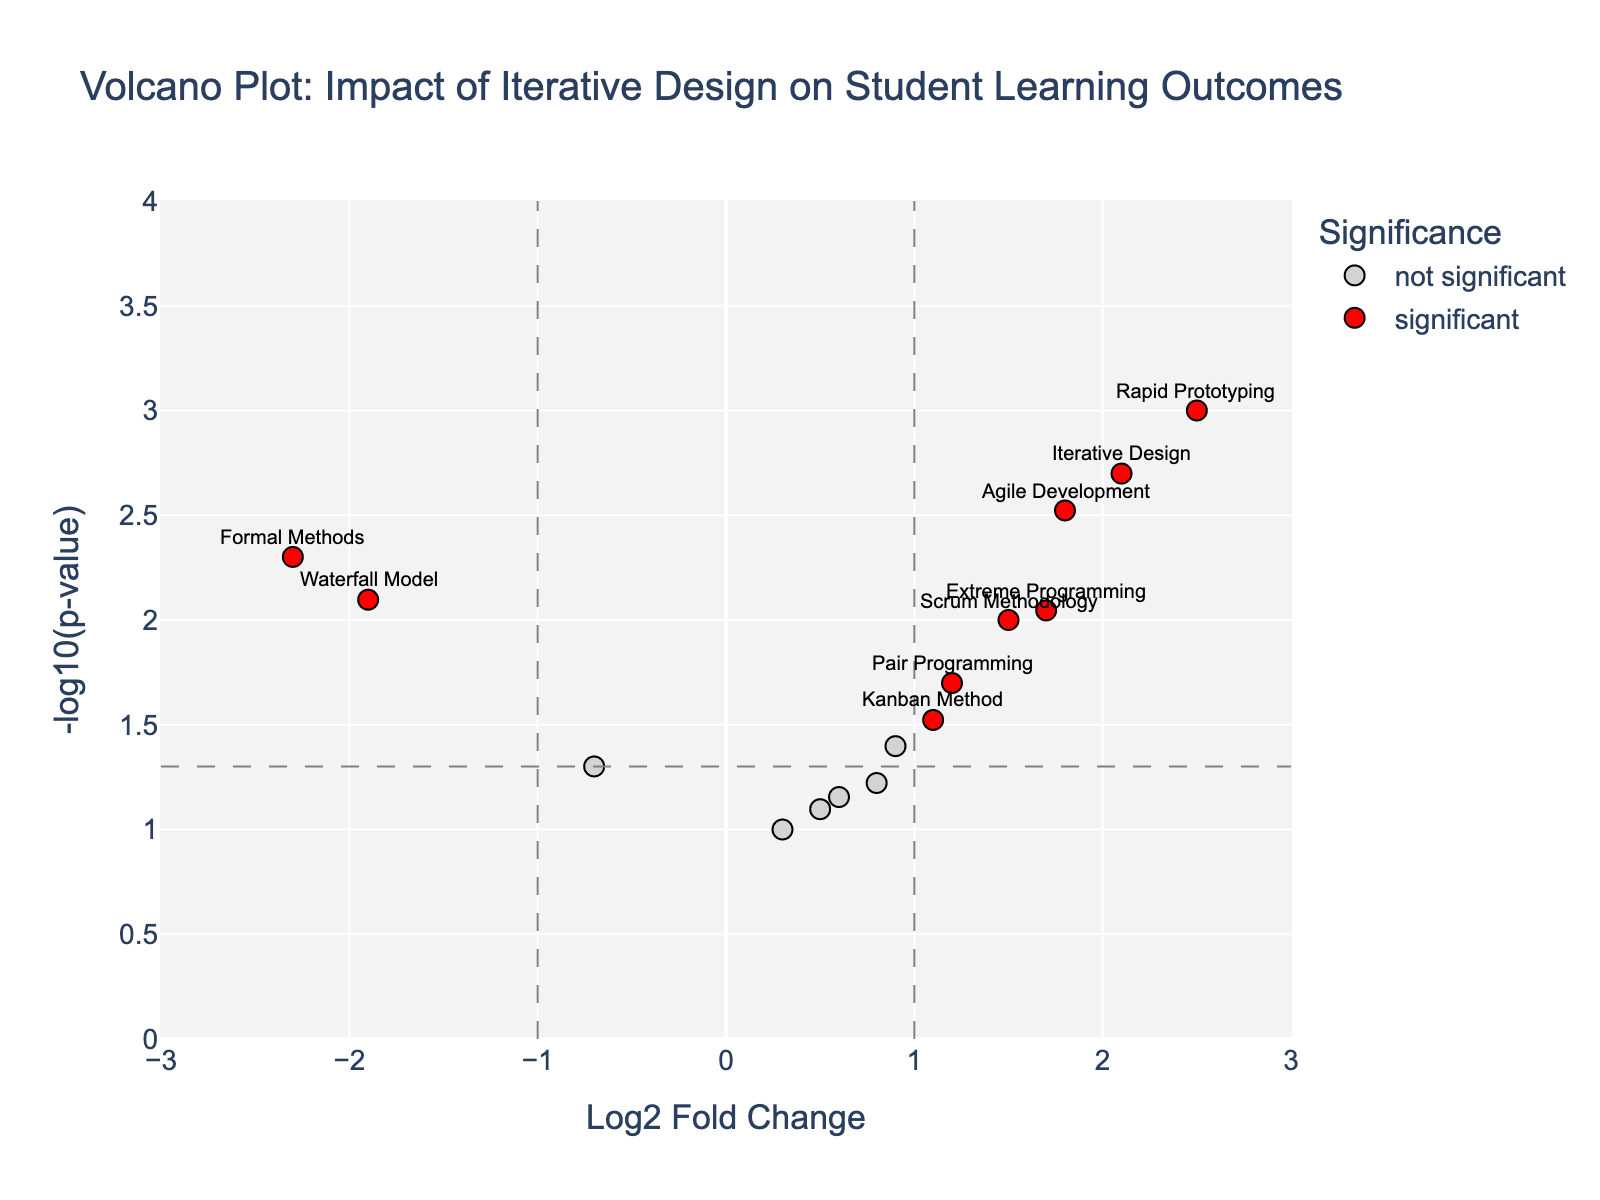What's the title of the plot? The title is clearly displayed at the top of the plot. It reads "Volcano Plot: Impact of Iterative Design on Student Learning Outcomes."
Answer: Volcano Plot: Impact of Iterative Design on Student Learning Outcomes What does the x-axis represent? The x-axis label is provided near the bottom of the plot. It represents the "Log2 Fold Change," which indicates the magnitude of change in student learning outcomes for different teaching methods.
Answer: Log2 Fold Change How many points are categorized as "significant"? Points categorized as "significant" are the ones colored in red. By visually counting these red markers, we can determine the total number.
Answer: 9 Which teaching method has the highest Log2 Fold Change and is it significant? By looking at the red markers and their annotations, "Rapid Prototyping" is the highest and it appears to be significant.
Answer: Rapid Prototyping What does the y-axis represent? The y-axis label near the left side of the plot indicates it represents "-log10(p-value)," which helps assess the significance of the results.
Answer: -log10(p-value) Which teaching method has the highest p-value? The highest p-value corresponds to the lowest -log10(p-value). Looking at the bottom-most point on the plot, "Version Control" is the teaching method with the highest p-value.
Answer: Version Control Of the methods categorized as "significant," which has the lowest Log2 Fold Change? Among the red markers, the one with the lowest x-value (most negative Log2 Fold Change) corresponds to "Formal Methods."
Answer: Formal Methods Where are the threshold lines for Log2 Fold Change and p-value placed? Threshold lines are placed at Log2 Fold Change of +1 and -1 (vertical dashed lines) and p-value of 0.05 (-log10(p-value) = 1.3, horizontal dashed line).
Answer: Log2FC: ±1 and p-value: 0.05 Compare "Agile Development" and "Extreme Programming" in terms of their Log2 Fold Change and significance. "Agile Development" has a Log2 Fold Change of 1.8, while "Extreme Programming" has 1.7. Both are above the significance thresholds for Log2FC and p-value, so both are significant.
Answer: Agile Development: 1.8 (significant), Extreme Programming: 1.7 (significant) Identify two teaching methods that have Log2 Fold Changes below 0 but are not significant. By looking at grey markers left of the y-axis, "Continuous Integration" (-0.7) and "Waterfall Model" (-1.9) are the two methods with Log2 Fold Changes below 0 but are not significant.
Answer: Continuous Integration, Waterfall Model 